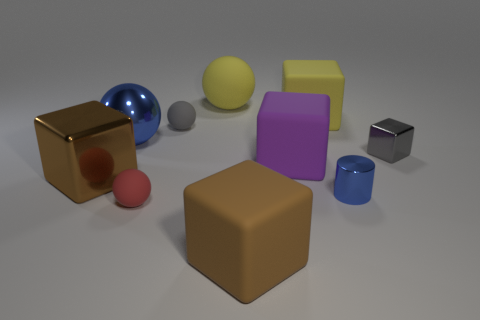Does the red sphere have the same size as the matte ball that is behind the large yellow matte block?
Offer a very short reply. No. What material is the large brown block behind the small red ball?
Give a very brief answer. Metal. There is a gray rubber thing that is behind the small cube; what number of big brown objects are to the left of it?
Your response must be concise. 1. Is there another small rubber thing of the same shape as the tiny red matte object?
Offer a very short reply. Yes. Do the yellow thing right of the large brown rubber thing and the sphere that is in front of the blue cylinder have the same size?
Offer a terse response. No. There is a tiny metal object in front of the large cube that is left of the blue ball; what shape is it?
Keep it short and to the point. Cylinder. What number of spheres are the same size as the purple cube?
Your answer should be compact. 2. Are there any red metal balls?
Make the answer very short. No. Are there any other things that have the same color as the tiny cube?
Your answer should be very brief. Yes. The brown object that is the same material as the tiny gray block is what shape?
Keep it short and to the point. Cube. 